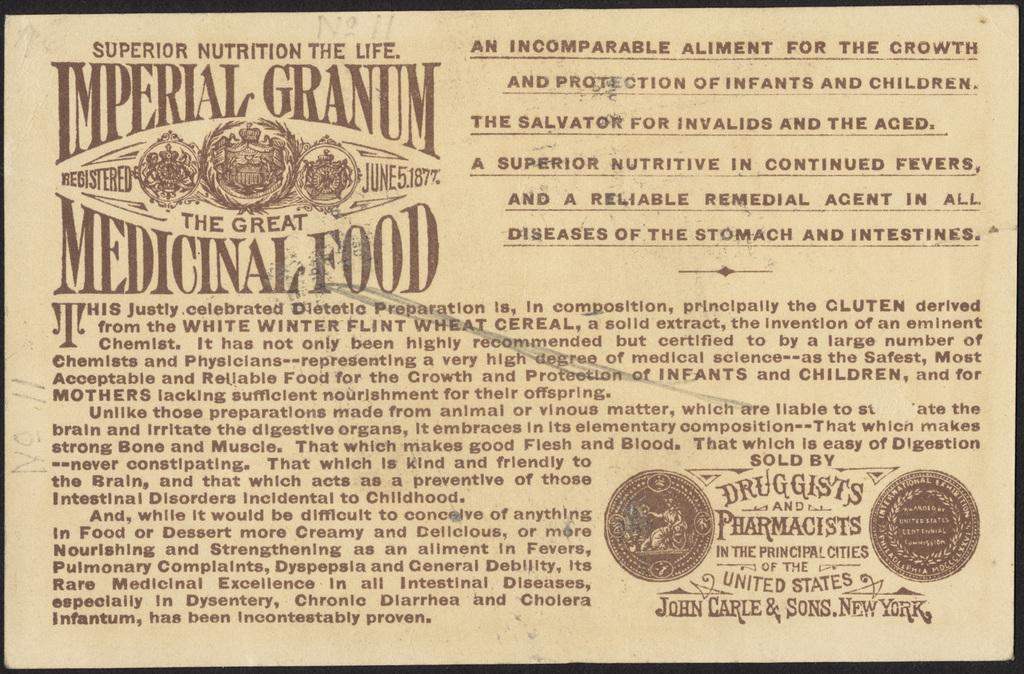<image>
Render a clear and concise summary of the photo. The ad says Imperial Granum is the Great Medical Food 